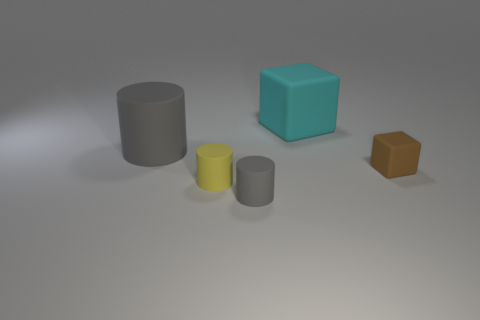Subtract all gray cylinders. How many cylinders are left? 1 Add 1 big cyan blocks. How many objects exist? 6 Subtract 1 cylinders. How many cylinders are left? 2 Subtract all yellow cylinders. How many cylinders are left? 2 Subtract all green cubes. Subtract all red spheres. How many cubes are left? 2 Subtract all brown cylinders. How many gray cubes are left? 0 Subtract all green metallic spheres. Subtract all cyan things. How many objects are left? 4 Add 1 yellow rubber objects. How many yellow rubber objects are left? 2 Add 1 large purple matte cylinders. How many large purple matte cylinders exist? 1 Subtract 0 green spheres. How many objects are left? 5 